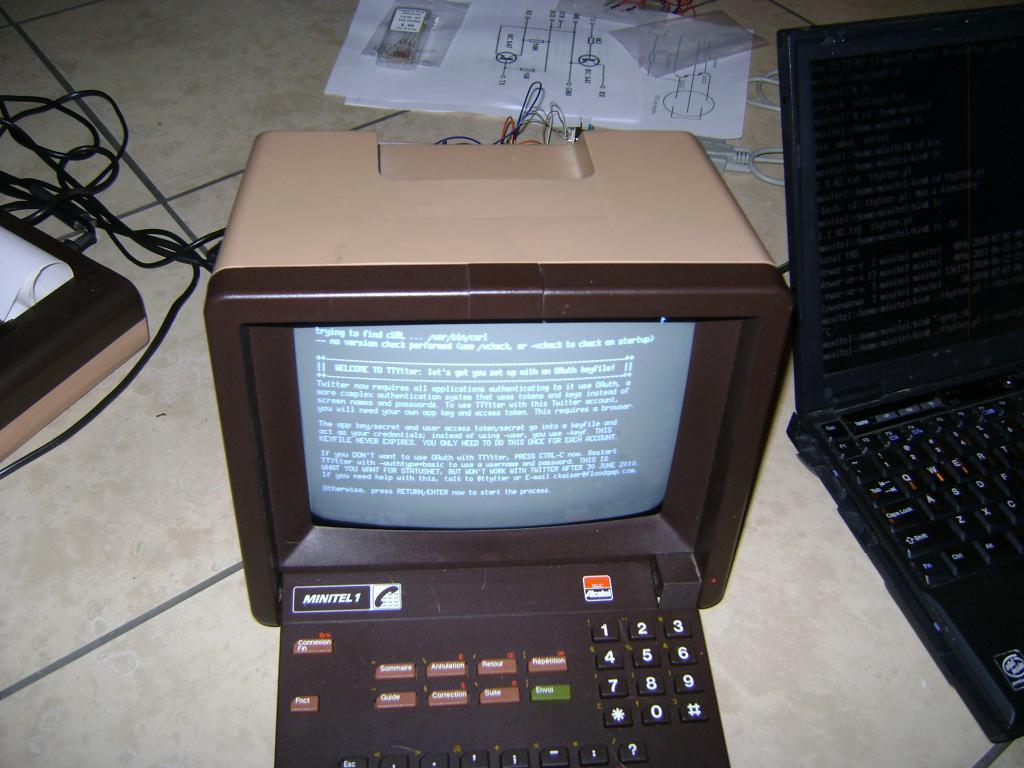Describe this image in one or two sentences. In this picture there is a black color computer placed on the flooring tile. Beside there is a laptop. Behind we can see the some white papers and cables. 